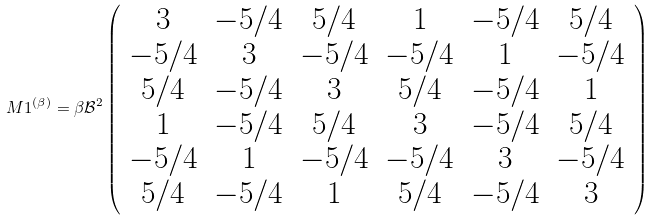Convert formula to latex. <formula><loc_0><loc_0><loc_500><loc_500>M 1 ^ { ( \beta ) } = \beta \mathcal { B } ^ { 2 } \left ( \begin{array} { c c c c c c } 3 & - 5 / 4 & 5 / 4 & 1 & - 5 / 4 & 5 / 4 \\ - 5 / 4 & 3 & - 5 / 4 & - 5 / 4 & 1 & - 5 / 4 \\ 5 / 4 & - 5 / 4 & 3 & 5 / 4 & - 5 / 4 & 1 \\ 1 & - 5 / 4 & 5 / 4 & 3 & - 5 / 4 & 5 / 4 \\ - 5 / 4 & 1 & - 5 / 4 & - 5 / 4 & 3 & - 5 / 4 \\ 5 / 4 & - 5 / 4 & 1 & 5 / 4 & - 5 / 4 & 3 \end{array} \right )</formula> 